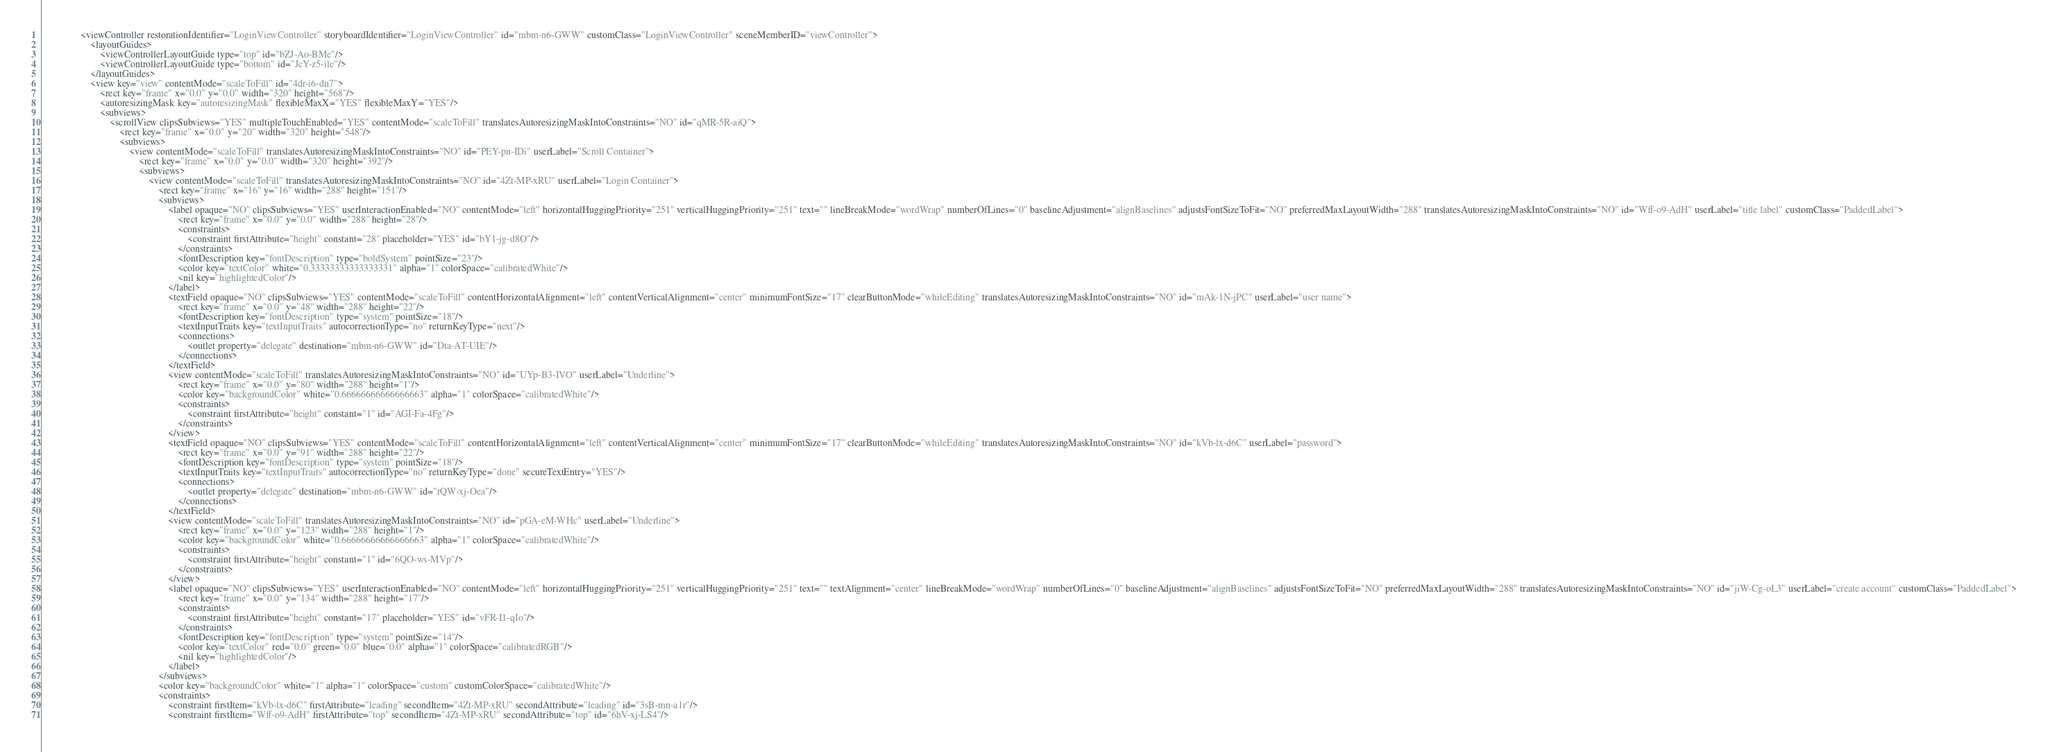Convert code to text. <code><loc_0><loc_0><loc_500><loc_500><_XML_>                <viewController restorationIdentifier="LoginViewController" storyboardIdentifier="LoginViewController" id="mbm-n6-GWW" customClass="LoginViewController" sceneMemberID="viewController">
                    <layoutGuides>
                        <viewControllerLayoutGuide type="top" id="bZJ-Ao-BMe"/>
                        <viewControllerLayoutGuide type="bottom" id="JcY-z5-ile"/>
                    </layoutGuides>
                    <view key="view" contentMode="scaleToFill" id="4dr-i6-dn7">
                        <rect key="frame" x="0.0" y="0.0" width="320" height="568"/>
                        <autoresizingMask key="autoresizingMask" flexibleMaxX="YES" flexibleMaxY="YES"/>
                        <subviews>
                            <scrollView clipsSubviews="YES" multipleTouchEnabled="YES" contentMode="scaleToFill" translatesAutoresizingMaskIntoConstraints="NO" id="qMR-5R-aiQ">
                                <rect key="frame" x="0.0" y="20" width="320" height="548"/>
                                <subviews>
                                    <view contentMode="scaleToFill" translatesAutoresizingMaskIntoConstraints="NO" id="PEY-pn-IDi" userLabel="Scroll Container">
                                        <rect key="frame" x="0.0" y="0.0" width="320" height="392"/>
                                        <subviews>
                                            <view contentMode="scaleToFill" translatesAutoresizingMaskIntoConstraints="NO" id="4Zt-MP-xRU" userLabel="Login Container">
                                                <rect key="frame" x="16" y="16" width="288" height="151"/>
                                                <subviews>
                                                    <label opaque="NO" clipsSubviews="YES" userInteractionEnabled="NO" contentMode="left" horizontalHuggingPriority="251" verticalHuggingPriority="251" text="" lineBreakMode="wordWrap" numberOfLines="0" baselineAdjustment="alignBaselines" adjustsFontSizeToFit="NO" preferredMaxLayoutWidth="288" translatesAutoresizingMaskIntoConstraints="NO" id="Wff-o9-AdH" userLabel="title label" customClass="PaddedLabel">
                                                        <rect key="frame" x="0.0" y="0.0" width="288" height="28"/>
                                                        <constraints>
                                                            <constraint firstAttribute="height" constant="28" placeholder="YES" id="bY1-jg-d8O"/>
                                                        </constraints>
                                                        <fontDescription key="fontDescription" type="boldSystem" pointSize="23"/>
                                                        <color key="textColor" white="0.33333333333333331" alpha="1" colorSpace="calibratedWhite"/>
                                                        <nil key="highlightedColor"/>
                                                    </label>
                                                    <textField opaque="NO" clipsSubviews="YES" contentMode="scaleToFill" contentHorizontalAlignment="left" contentVerticalAlignment="center" minimumFontSize="17" clearButtonMode="whileEditing" translatesAutoresizingMaskIntoConstraints="NO" id="mAk-1N-jPC" userLabel="user name">
                                                        <rect key="frame" x="0.0" y="48" width="288" height="22"/>
                                                        <fontDescription key="fontDescription" type="system" pointSize="18"/>
                                                        <textInputTraits key="textInputTraits" autocorrectionType="no" returnKeyType="next"/>
                                                        <connections>
                                                            <outlet property="delegate" destination="mbm-n6-GWW" id="Dta-AT-UIE"/>
                                                        </connections>
                                                    </textField>
                                                    <view contentMode="scaleToFill" translatesAutoresizingMaskIntoConstraints="NO" id="UYp-B3-IVO" userLabel="Underline">
                                                        <rect key="frame" x="0.0" y="80" width="288" height="1"/>
                                                        <color key="backgroundColor" white="0.66666666666666663" alpha="1" colorSpace="calibratedWhite"/>
                                                        <constraints>
                                                            <constraint firstAttribute="height" constant="1" id="AGI-Fa-4Fg"/>
                                                        </constraints>
                                                    </view>
                                                    <textField opaque="NO" clipsSubviews="YES" contentMode="scaleToFill" contentHorizontalAlignment="left" contentVerticalAlignment="center" minimumFontSize="17" clearButtonMode="whileEditing" translatesAutoresizingMaskIntoConstraints="NO" id="kVb-lx-d6C" userLabel="password">
                                                        <rect key="frame" x="0.0" y="91" width="288" height="22"/>
                                                        <fontDescription key="fontDescription" type="system" pointSize="18"/>
                                                        <textInputTraits key="textInputTraits" autocorrectionType="no" returnKeyType="done" secureTextEntry="YES"/>
                                                        <connections>
                                                            <outlet property="delegate" destination="mbm-n6-GWW" id="rQW-xj-Oea"/>
                                                        </connections>
                                                    </textField>
                                                    <view contentMode="scaleToFill" translatesAutoresizingMaskIntoConstraints="NO" id="pGA-eM-WHc" userLabel="Underline">
                                                        <rect key="frame" x="0.0" y="123" width="288" height="1"/>
                                                        <color key="backgroundColor" white="0.66666666666666663" alpha="1" colorSpace="calibratedWhite"/>
                                                        <constraints>
                                                            <constraint firstAttribute="height" constant="1" id="6QO-ws-MVp"/>
                                                        </constraints>
                                                    </view>
                                                    <label opaque="NO" clipsSubviews="YES" userInteractionEnabled="NO" contentMode="left" horizontalHuggingPriority="251" verticalHuggingPriority="251" text="" textAlignment="center" lineBreakMode="wordWrap" numberOfLines="0" baselineAdjustment="alignBaselines" adjustsFontSizeToFit="NO" preferredMaxLayoutWidth="288" translatesAutoresizingMaskIntoConstraints="NO" id="jiW-Cg-oL3" userLabel="create account" customClass="PaddedLabel">
                                                        <rect key="frame" x="0.0" y="134" width="288" height="17"/>
                                                        <constraints>
                                                            <constraint firstAttribute="height" constant="17" placeholder="YES" id="vFR-I1-qIo"/>
                                                        </constraints>
                                                        <fontDescription key="fontDescription" type="system" pointSize="14"/>
                                                        <color key="textColor" red="0.0" green="0.0" blue="0.0" alpha="1" colorSpace="calibratedRGB"/>
                                                        <nil key="highlightedColor"/>
                                                    </label>
                                                </subviews>
                                                <color key="backgroundColor" white="1" alpha="1" colorSpace="custom" customColorSpace="calibratedWhite"/>
                                                <constraints>
                                                    <constraint firstItem="kVb-lx-d6C" firstAttribute="leading" secondItem="4Zt-MP-xRU" secondAttribute="leading" id="3sB-mn-a1r"/>
                                                    <constraint firstItem="Wff-o9-AdH" firstAttribute="top" secondItem="4Zt-MP-xRU" secondAttribute="top" id="6hV-xj-LS4"/></code> 